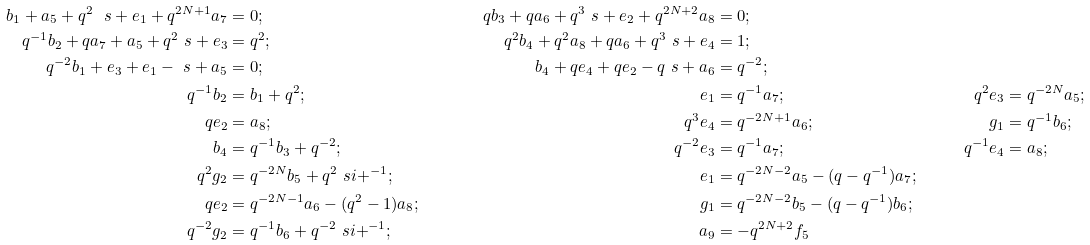Convert formula to latex. <formula><loc_0><loc_0><loc_500><loc_500>b _ { 1 } + a _ { 5 } + q ^ { 2 } \ s + e _ { 1 } + q ^ { 2 N + 1 } a _ { 7 } & = 0 ; \quad & q b _ { 3 } + q a _ { 6 } + q ^ { 3 } \ s + e _ { 2 } + q ^ { 2 N + 2 } a _ { 8 } & = 0 ; \\ q ^ { - 1 } b _ { 2 } + q a _ { 7 } + a _ { 5 } + q ^ { 2 } \ s + e _ { 3 } & = q ^ { 2 } ; \quad & q ^ { 2 } b _ { 4 } + q ^ { 2 } a _ { 8 } + q a _ { 6 } + q ^ { 3 } \ s + e _ { 4 } & = 1 ; \\ q ^ { - 2 } b _ { 1 } + e _ { 3 } + e _ { 1 } - \ s + a _ { 5 } & = 0 ; \quad & b _ { 4 } + q e _ { 4 } + q e _ { 2 } - q \ s + a _ { 6 } & = q ^ { - 2 } ; \\ q ^ { - 1 } b _ { 2 } & = b _ { 1 } + q ^ { 2 } ; \quad & e _ { 1 } & = q ^ { - 1 } a _ { 7 } ; \quad & q ^ { 2 } e _ { 3 } & = q ^ { - 2 N } a _ { 5 } ; \\ q e _ { 2 } & = a _ { 8 } ; \quad & q ^ { 3 } e _ { 4 } & = q ^ { - 2 N + 1 } a _ { 6 } ; \quad & g _ { 1 } & = q ^ { - 1 } b _ { 6 } ; \\ b _ { 4 } & = q ^ { - 1 } b _ { 3 } + q ^ { - 2 } ; \quad & q ^ { - 2 } e _ { 3 } & = q ^ { - 1 } a _ { 7 } ; \quad & q ^ { - 1 } e _ { 4 } & = a _ { 8 } ; \\ q ^ { 2 } g _ { 2 } & = q ^ { - 2 N } b _ { 5 } + q ^ { 2 } { \ s i + } ^ { - 1 } ; \quad & e _ { 1 } & = q ^ { - 2 N - 2 } a _ { 5 } - ( q - q ^ { - 1 } ) a _ { 7 } ; \\ q e _ { 2 } & = q ^ { - 2 N - 1 } a _ { 6 } - ( q ^ { 2 } - 1 ) a _ { 8 } ; \quad & g _ { 1 } & = q ^ { - 2 N - 2 } b _ { 5 } - ( q - q ^ { - 1 } ) b _ { 6 } ; \\ q ^ { - 2 } g _ { 2 } & = q ^ { - 1 } b _ { 6 } + q ^ { - 2 } { \ s i + } ^ { - 1 } ; \quad & a _ { 9 } & = - q ^ { 2 N + 2 } f _ { 5 }</formula> 